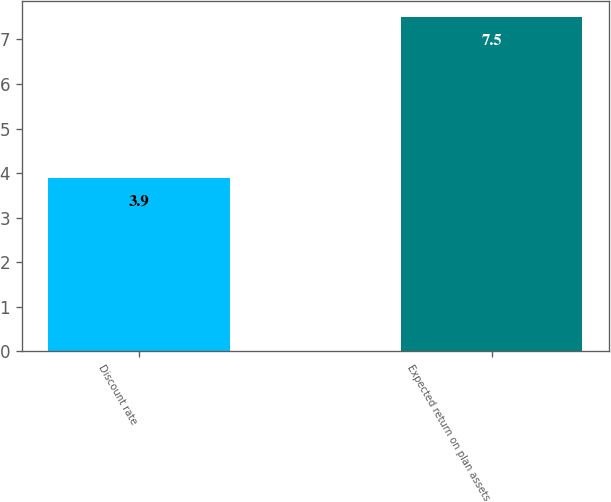Convert chart to OTSL. <chart><loc_0><loc_0><loc_500><loc_500><bar_chart><fcel>Discount rate<fcel>Expected return on plan assets<nl><fcel>3.9<fcel>7.5<nl></chart> 